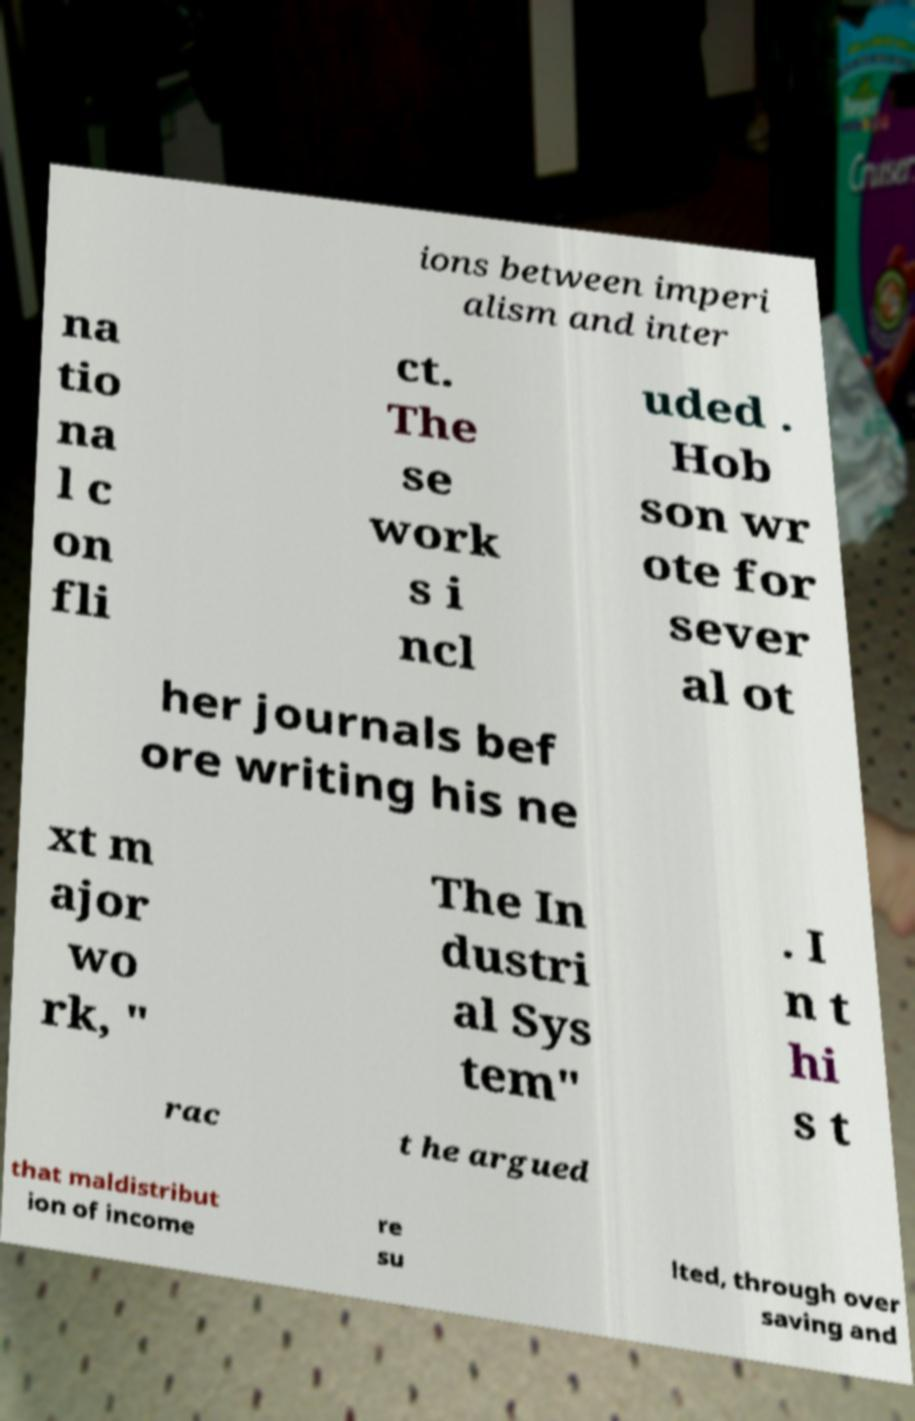For documentation purposes, I need the text within this image transcribed. Could you provide that? ions between imperi alism and inter na tio na l c on fli ct. The se work s i ncl uded . Hob son wr ote for sever al ot her journals bef ore writing his ne xt m ajor wo rk, " The In dustri al Sys tem" . I n t hi s t rac t he argued that maldistribut ion of income re su lted, through over saving and 